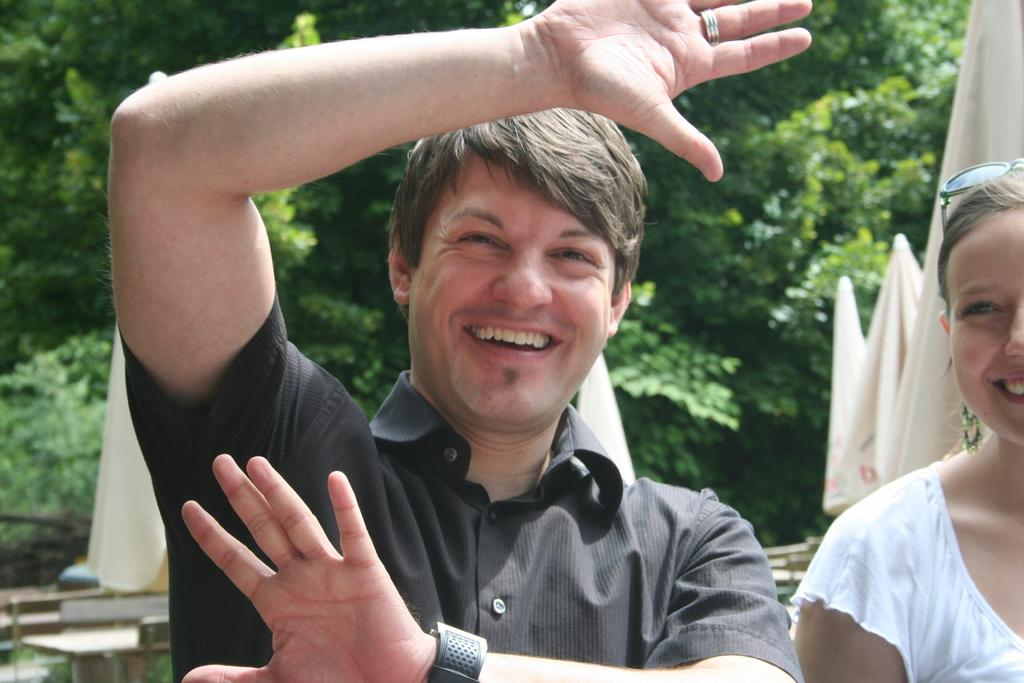How many people are in the image? There are two persons in the image. What can be seen in the image besides the people? Clothes and wooden objects are visible in the image. What is visible in the background of the image? There is a group of trees in the background of the image. What type of leather material can be seen on the fang in the image? There is no leather or fang present in the image. 